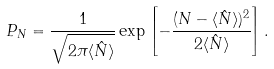<formula> <loc_0><loc_0><loc_500><loc_500>P _ { N } = \frac { 1 } { \sqrt { 2 \pi \langle \hat { N } \rangle } } \exp \left [ { - \frac { ( N - \langle \hat { N } \rangle ) ^ { 2 } } { 2 \langle \hat { N } \rangle } } \right ] .</formula> 